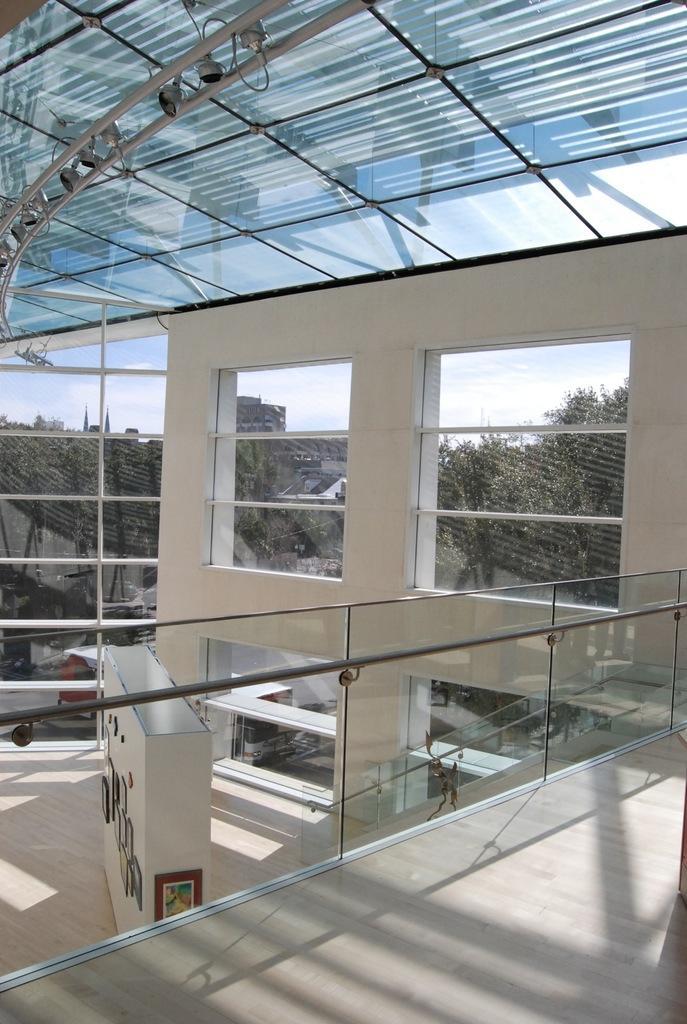How would you summarize this image in a sentence or two? In the image we can see the internal structure of the building. These are the windows and out of the windows we can see trees and a cloudy sky. This is a frame, light and roof. 